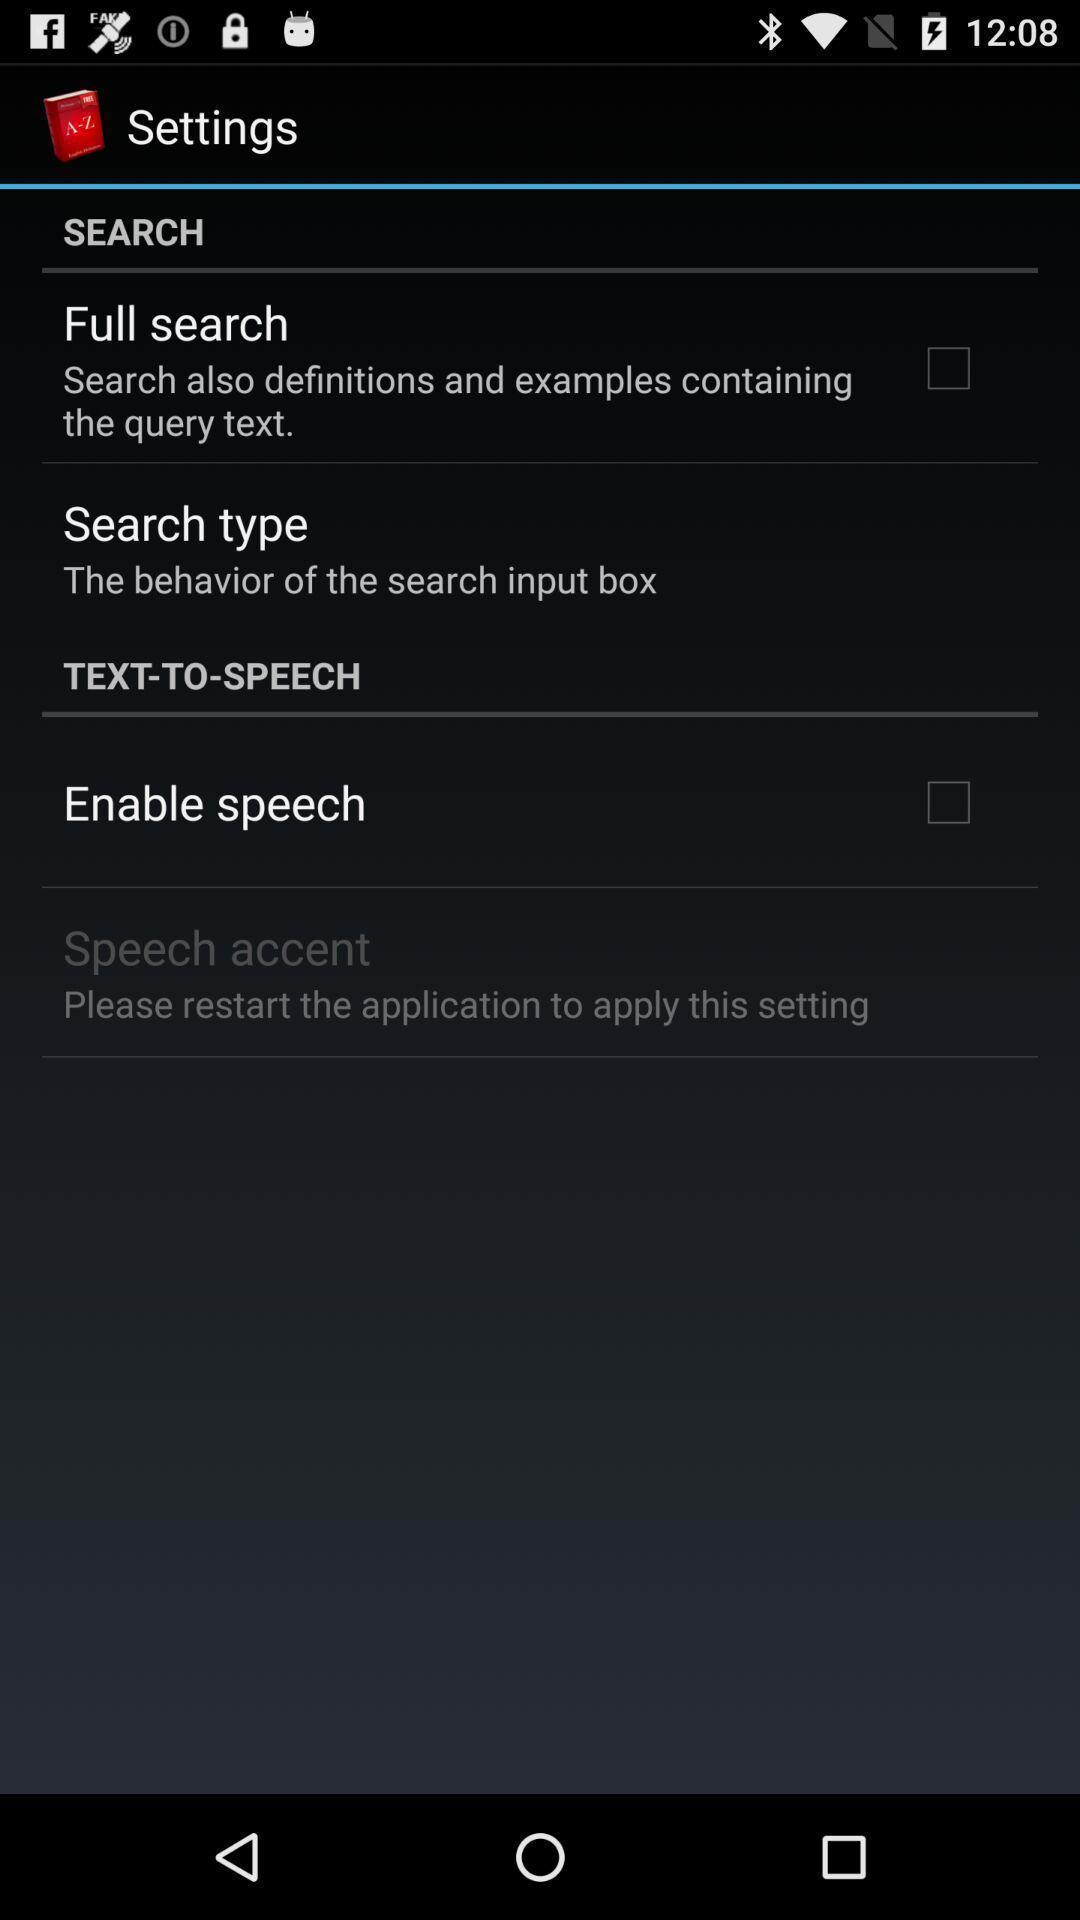What can you discern from this picture? Screen showing settings page. 